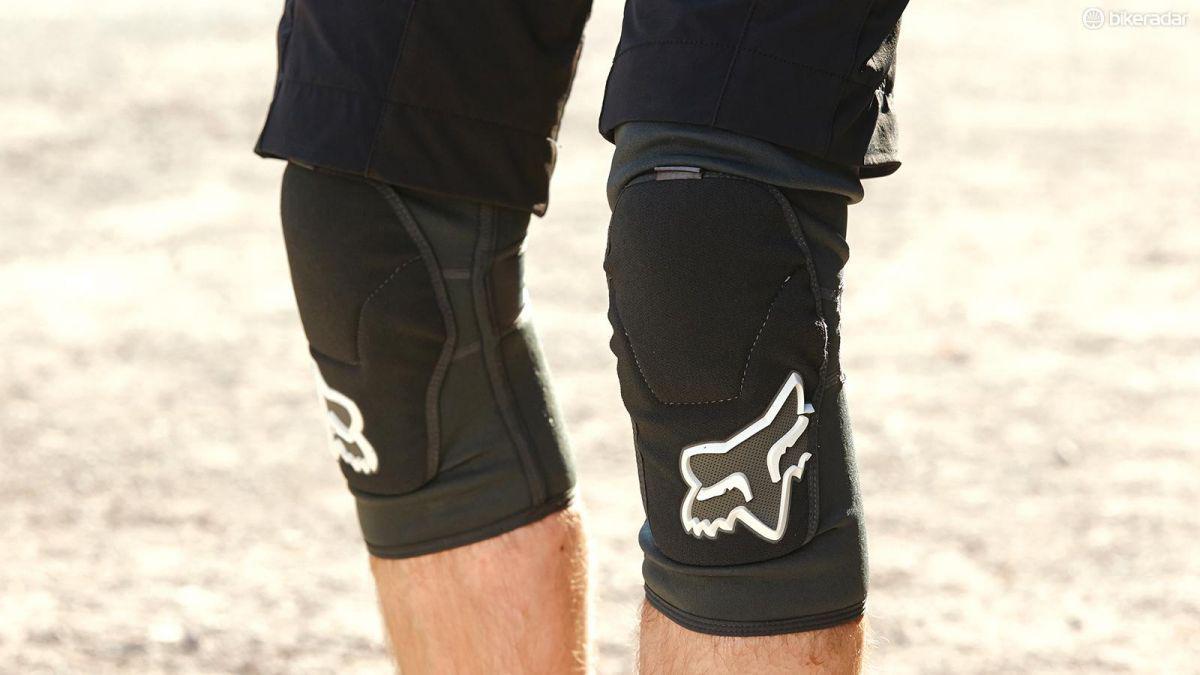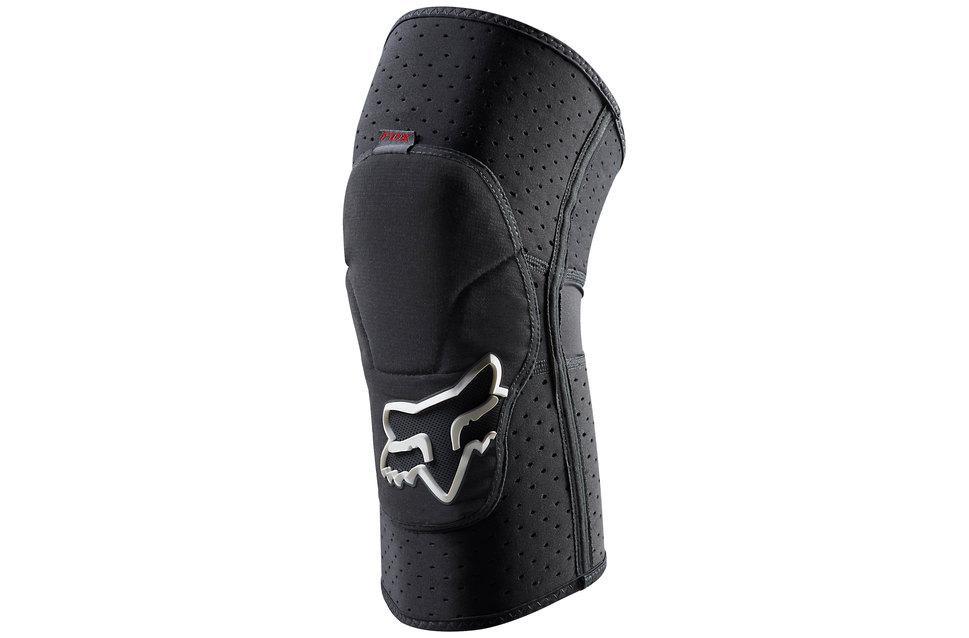The first image is the image on the left, the second image is the image on the right. For the images displayed, is the sentence "At least one knee pad is not worn by a human." factually correct? Answer yes or no. Yes. 